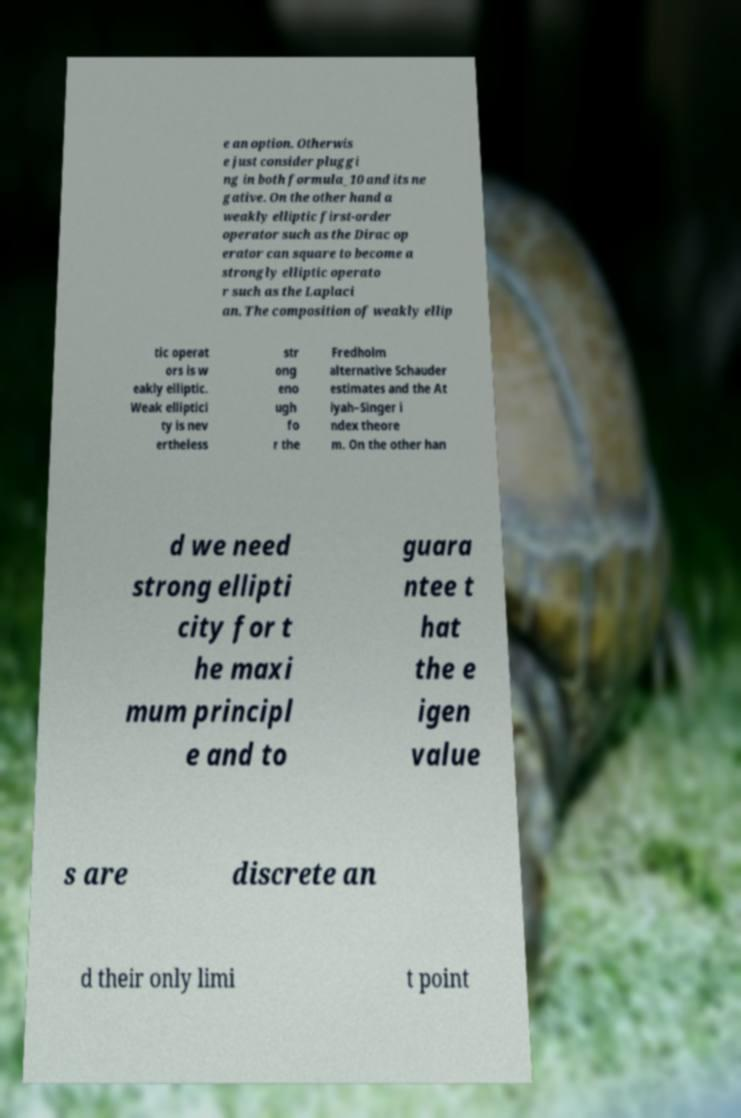Could you assist in decoding the text presented in this image and type it out clearly? e an option. Otherwis e just consider pluggi ng in both formula_10 and its ne gative. On the other hand a weakly elliptic first-order operator such as the Dirac op erator can square to become a strongly elliptic operato r such as the Laplaci an. The composition of weakly ellip tic operat ors is w eakly elliptic. Weak elliptici ty is nev ertheless str ong eno ugh fo r the Fredholm alternative Schauder estimates and the At iyah–Singer i ndex theore m. On the other han d we need strong ellipti city for t he maxi mum principl e and to guara ntee t hat the e igen value s are discrete an d their only limi t point 